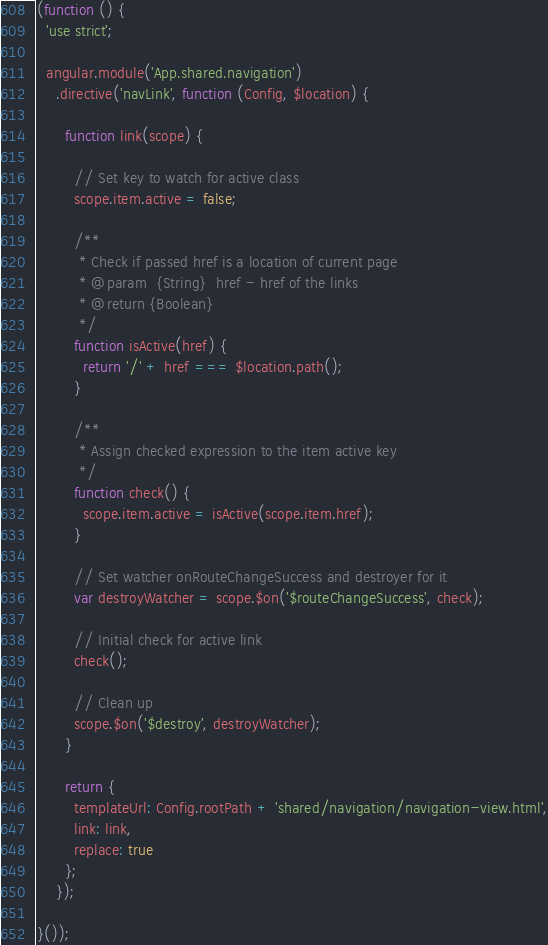<code> <loc_0><loc_0><loc_500><loc_500><_JavaScript_>(function () {
  'use strict';

  angular.module('App.shared.navigation')
    .directive('navLink', function (Config, $location) {

      function link(scope) {

        // Set key to watch for active class
        scope.item.active = false;

        /**
         * Check if passed href is a location of current page
         * @param  {String}  href - href of the links
         * @return {Boolean}
         */
        function isActive(href) {
          return '/' + href === $location.path();
        }

        /**
         * Assign checked expression to the item active key
         */
        function check() {
          scope.item.active = isActive(scope.item.href);
        }

        // Set watcher onRouteChangeSuccess and destroyer for it
        var destroyWatcher = scope.$on('$routeChangeSuccess', check);

        // Initial check for active link
        check();

        // Clean up
        scope.$on('$destroy', destroyWatcher);
      }

      return {
        templateUrl: Config.rootPath + 'shared/navigation/navigation-view.html',
        link: link,
        replace: true
      };
    });

}());</code> 